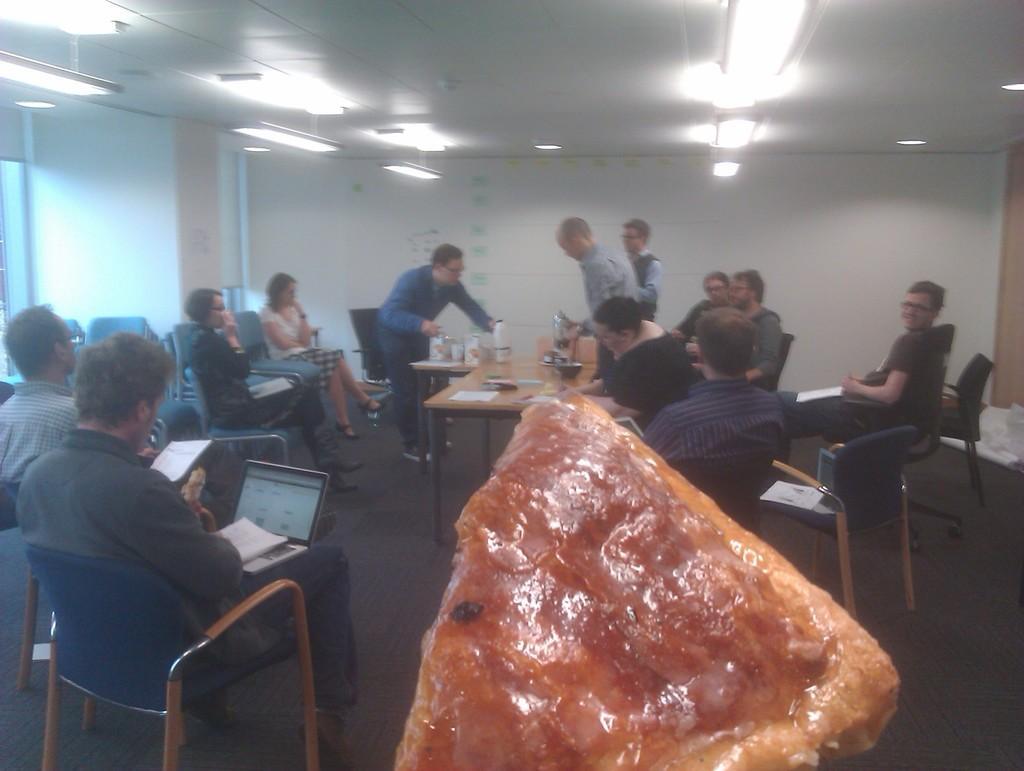How would you summarize this image in a sentence or two? There is a room with lot of chairs and tables, some people sitting on them operating laptops and a man serving drinks at one corner. on the other hand there are few people standing and talking with each other. 